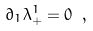<formula> <loc_0><loc_0><loc_500><loc_500>\partial _ { 1 } \lambda _ { + } ^ { 1 } = 0 \ ,</formula> 